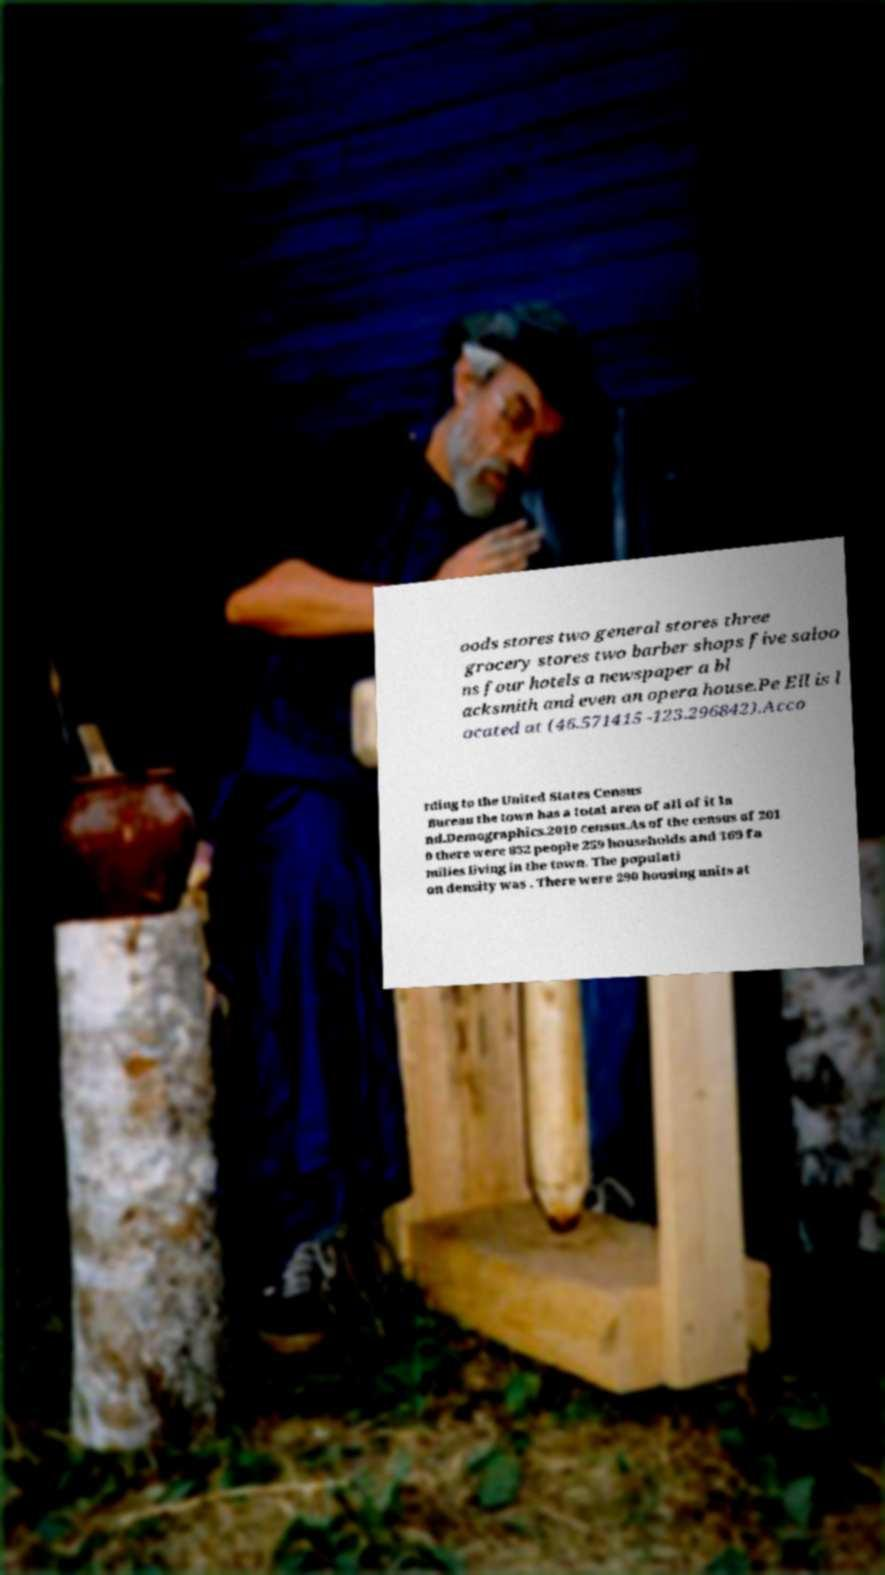Could you extract and type out the text from this image? oods stores two general stores three grocery stores two barber shops five saloo ns four hotels a newspaper a bl acksmith and even an opera house.Pe Ell is l ocated at (46.571415 -123.296842).Acco rding to the United States Census Bureau the town has a total area of all of it la nd.Demographics.2010 census.As of the census of 201 0 there were 632 people 259 households and 169 fa milies living in the town. The populati on density was . There were 290 housing units at 